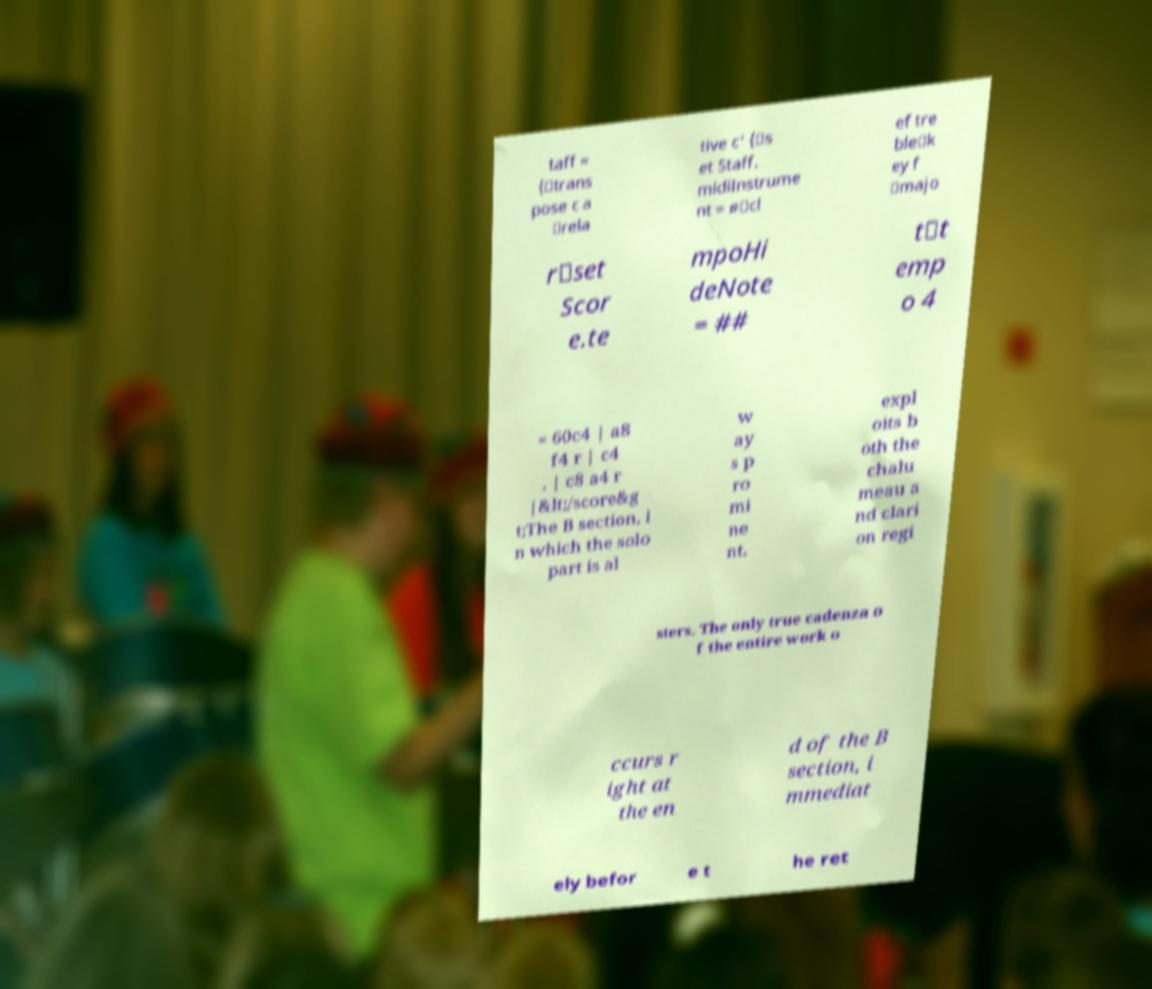I need the written content from this picture converted into text. Can you do that? taff = {\trans pose c a \rela tive c' {\s et Staff. midiInstrume nt = #\cl ef tre ble\k ey f \majo r\set Scor e.te mpoHi deNote = ## t\t emp o 4 = 60c4 | a8 f4 r | c4 . | c8 a4 r |&lt;/score&g t;The B section, i n which the solo part is al w ay s p ro mi ne nt, expl oits b oth the chalu meau a nd clari on regi sters. The only true cadenza o f the entire work o ccurs r ight at the en d of the B section, i mmediat ely befor e t he ret 